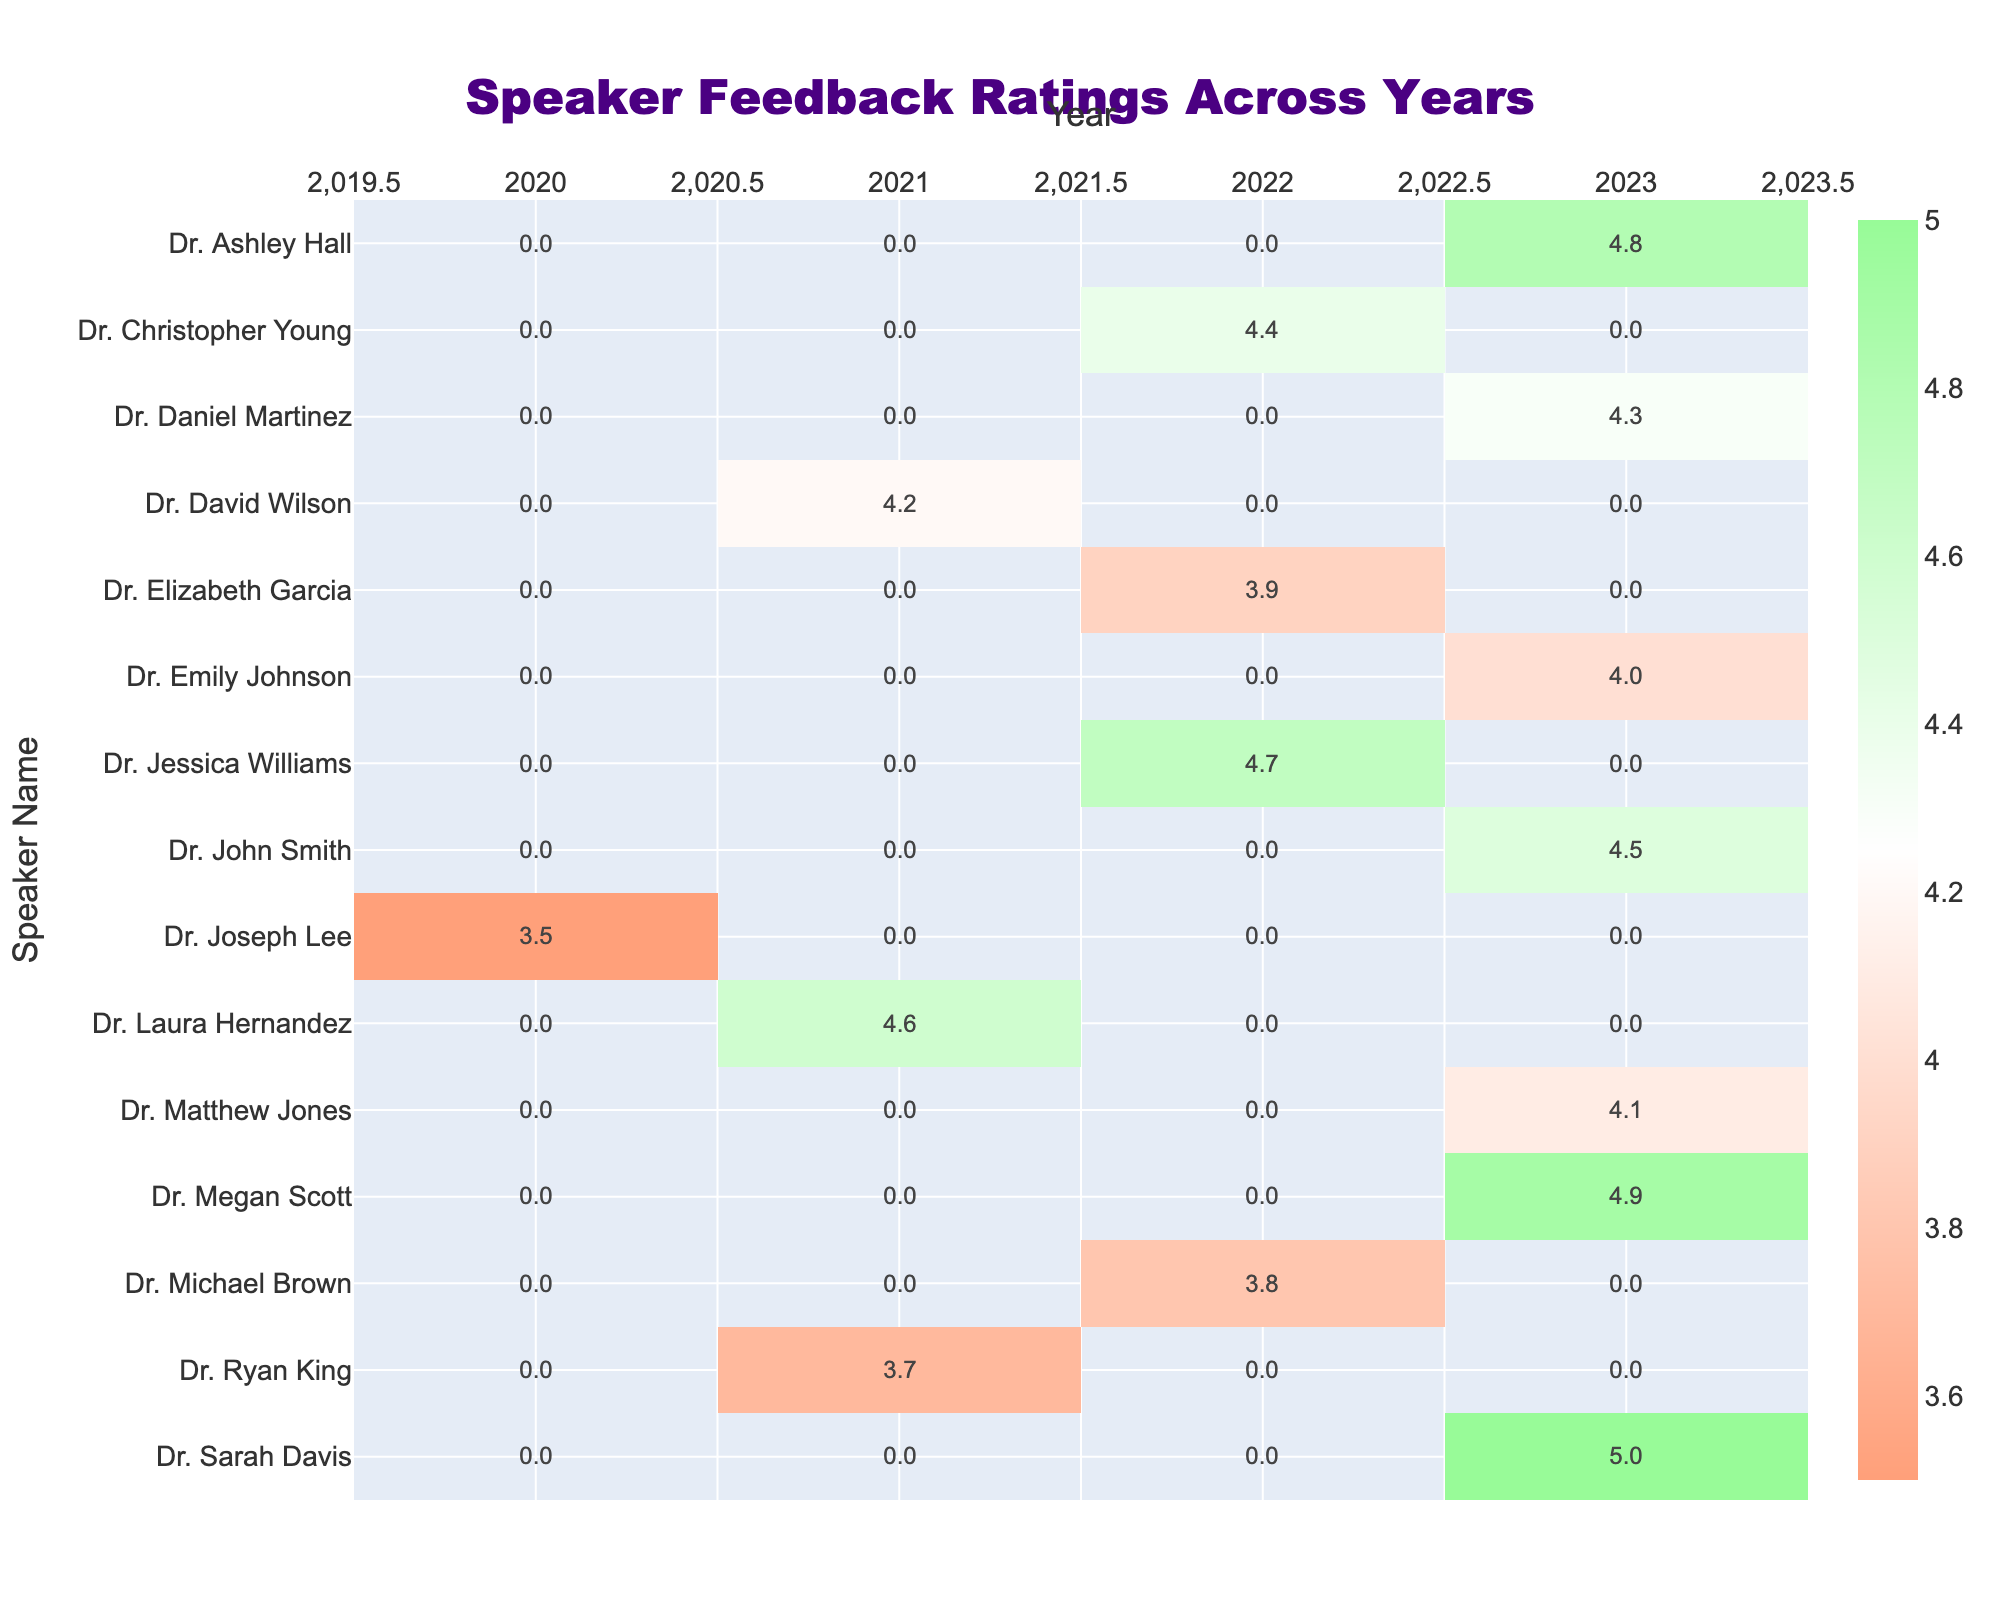What was the feedback rating for Dr. Sarah Davis in 2023? Looking at the row for Dr. Sarah Davis, the feedback rating for the year 2023 is 5.0.
Answer: 5.0 Which speaker had the highest rating in 2022? In the year 2022, comparing the ratings, Dr. Jessica Williams has the highest rating at 4.7, while others are lower.
Answer: 4.7 What is the average feedback rating for Dr. Daniel Martinez across all years? Dr. Daniel Martinez only has a rating for 2023, which is 4.3. Since there's only one rating, the average is 4.3.
Answer: 4.3 Did Dr. Emily Johnson receive a higher rating than Dr. Ryan King in 2023? Dr. Emily Johnson's rating in 2023 is 4.0, while Dr. Ryan King's rating in 2021 is 3.7. Since 4.0 is higher than 3.7, the answer is yes.
Answer: Yes What is the difference between the highest and lowest ratings for the year 2023? The highest rating in 2023 is 5.0 (Dr. Sarah Davis) and the lowest is 4.0 (Dr. Emily Johnson). Calculating the difference, 5.0 - 4.0 = 1.0.
Answer: 1.0 Which speaker has the most consistent ratings across the years, if any? To determine the most consistent speaker, we look for a speaker with ratings available across multiple years that do not vary much. Dr. Matthew Jones has a stable rating of 4.1 in 2023 and only has one data point, which suggests no variance. Hence, no speaker shows consistency across many years.
Answer: None How many speakers received a rating of 4.0 or higher in 2023? In the year 2023, analyzing the ratings, the following speakers received 4.0 or higher: Dr. Sarah Davis (5.0), Dr. Ashley Hall (4.8), Dr. Megan Scott (4.9), Dr. Daniel Martinez (4.3), Dr. Matthew Jones (4.1), and Dr. John Smith (4.5). Counting these gives a total of 6 speakers.
Answer: 6 Which specialty had the speaker with the highest rating in the dataset? The highest rating recorded in the dataset is 5.0, which belongs to Dr. Sarah Davis, whose specialty is General Cardiology.
Answer: General Cardiology What is the median feedback rating for all speakers in 2022? For the year 2022, the ratings are 4.7, 3.8, 4.4, 3.9. To find the median, we arrange the ratings in order: 3.8, 3.9, 4.4, 4.7. The median is the average of the two middle numbers (3.9 + 4.4) / 2 = 4.15.
Answer: 4.15 Which speaker had the least rating in 2020? The only rating for the year 2020 is for Dr. Joseph Lee, who received a rating of 3.5. Since he is the only one listed for that year, he has the least rating.
Answer: Dr. Joseph Lee 